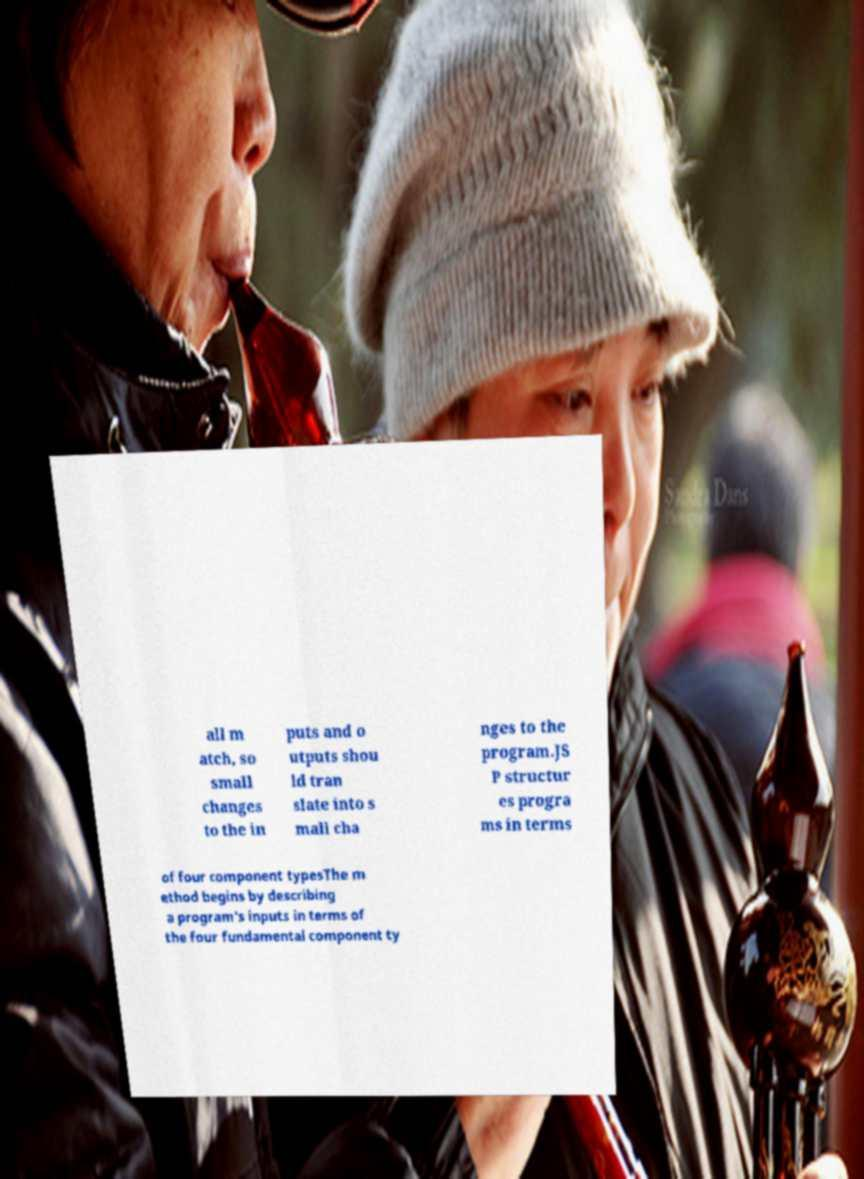What messages or text are displayed in this image? I need them in a readable, typed format. all m atch, so small changes to the in puts and o utputs shou ld tran slate into s mall cha nges to the program.JS P structur es progra ms in terms of four component typesThe m ethod begins by describing a program's inputs in terms of the four fundamental component ty 